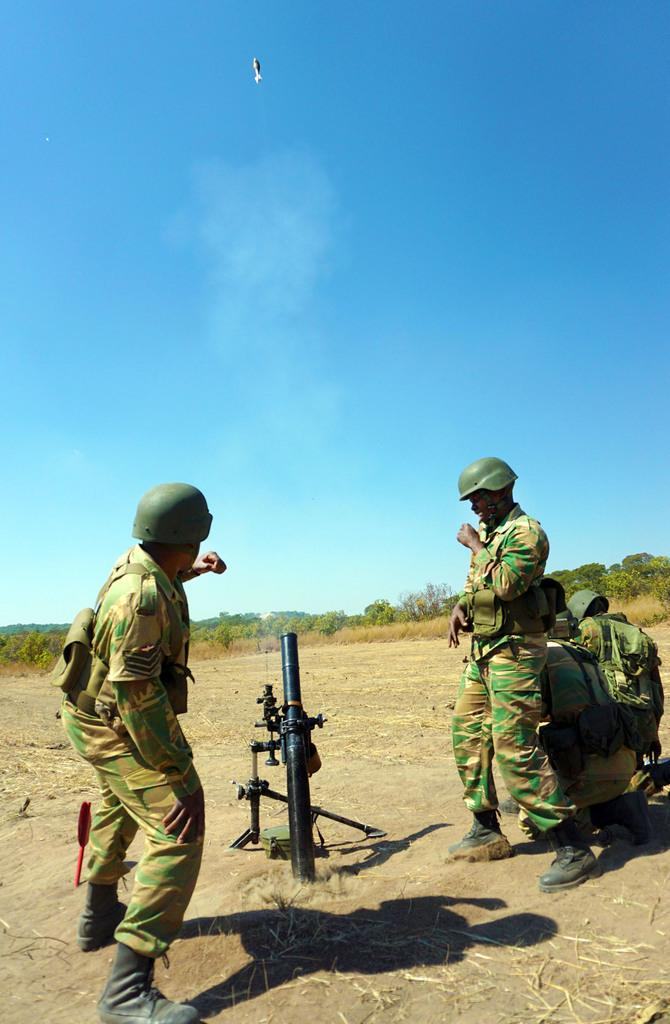What are the people in the image wearing? The people in the image are wearing military dress. What type of headgear are they wearing? They are wearing helmets. What can be seen on the ground in the image? There is a weapon on the ground in the image. What is visible in the background of the image? Trees, plants, and the sky are visible in the background of the image. What is the caption for the image? There is no caption present in the image, as it is a still photograph. What part of the weapon is missing in the image? There is no indication that any part of the weapon is missing in the image; it appears to be complete. 